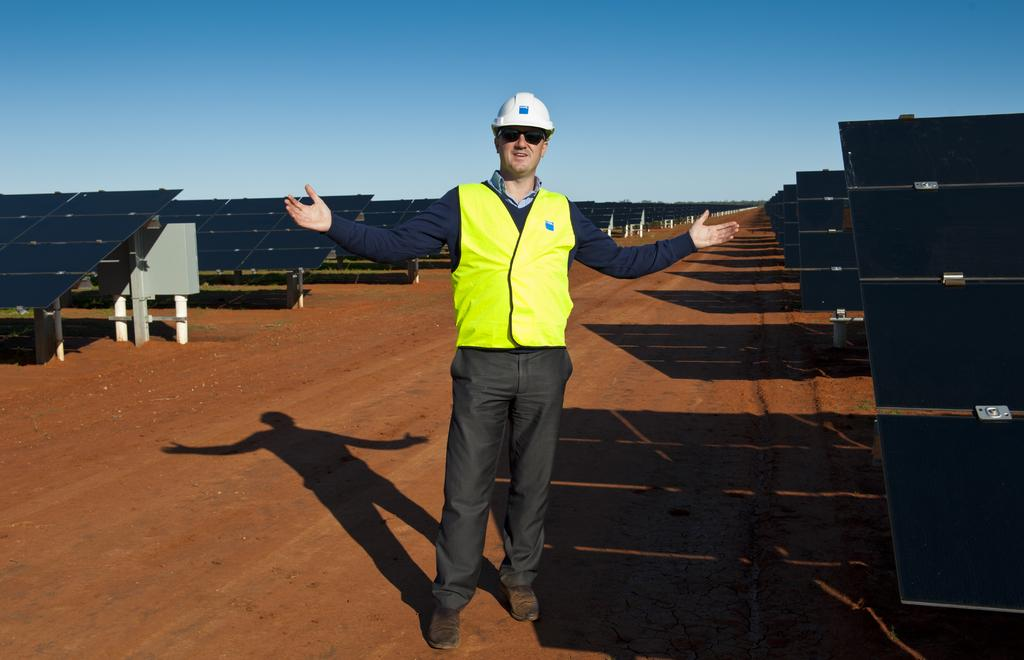What is the person in the image wearing on their head? The person in the image is wearing a helmet. What can be seen beneath the person's feet in the image? The ground is visible in the image. What type of energy-generating devices are present in the image? There are solar panels in the image. What part of the natural environment is visible in the image? The sky is visible in the image. What verse is the person reciting in the image? There is no indication in the image that the person is reciting a verse, so it cannot be determined from the picture. 